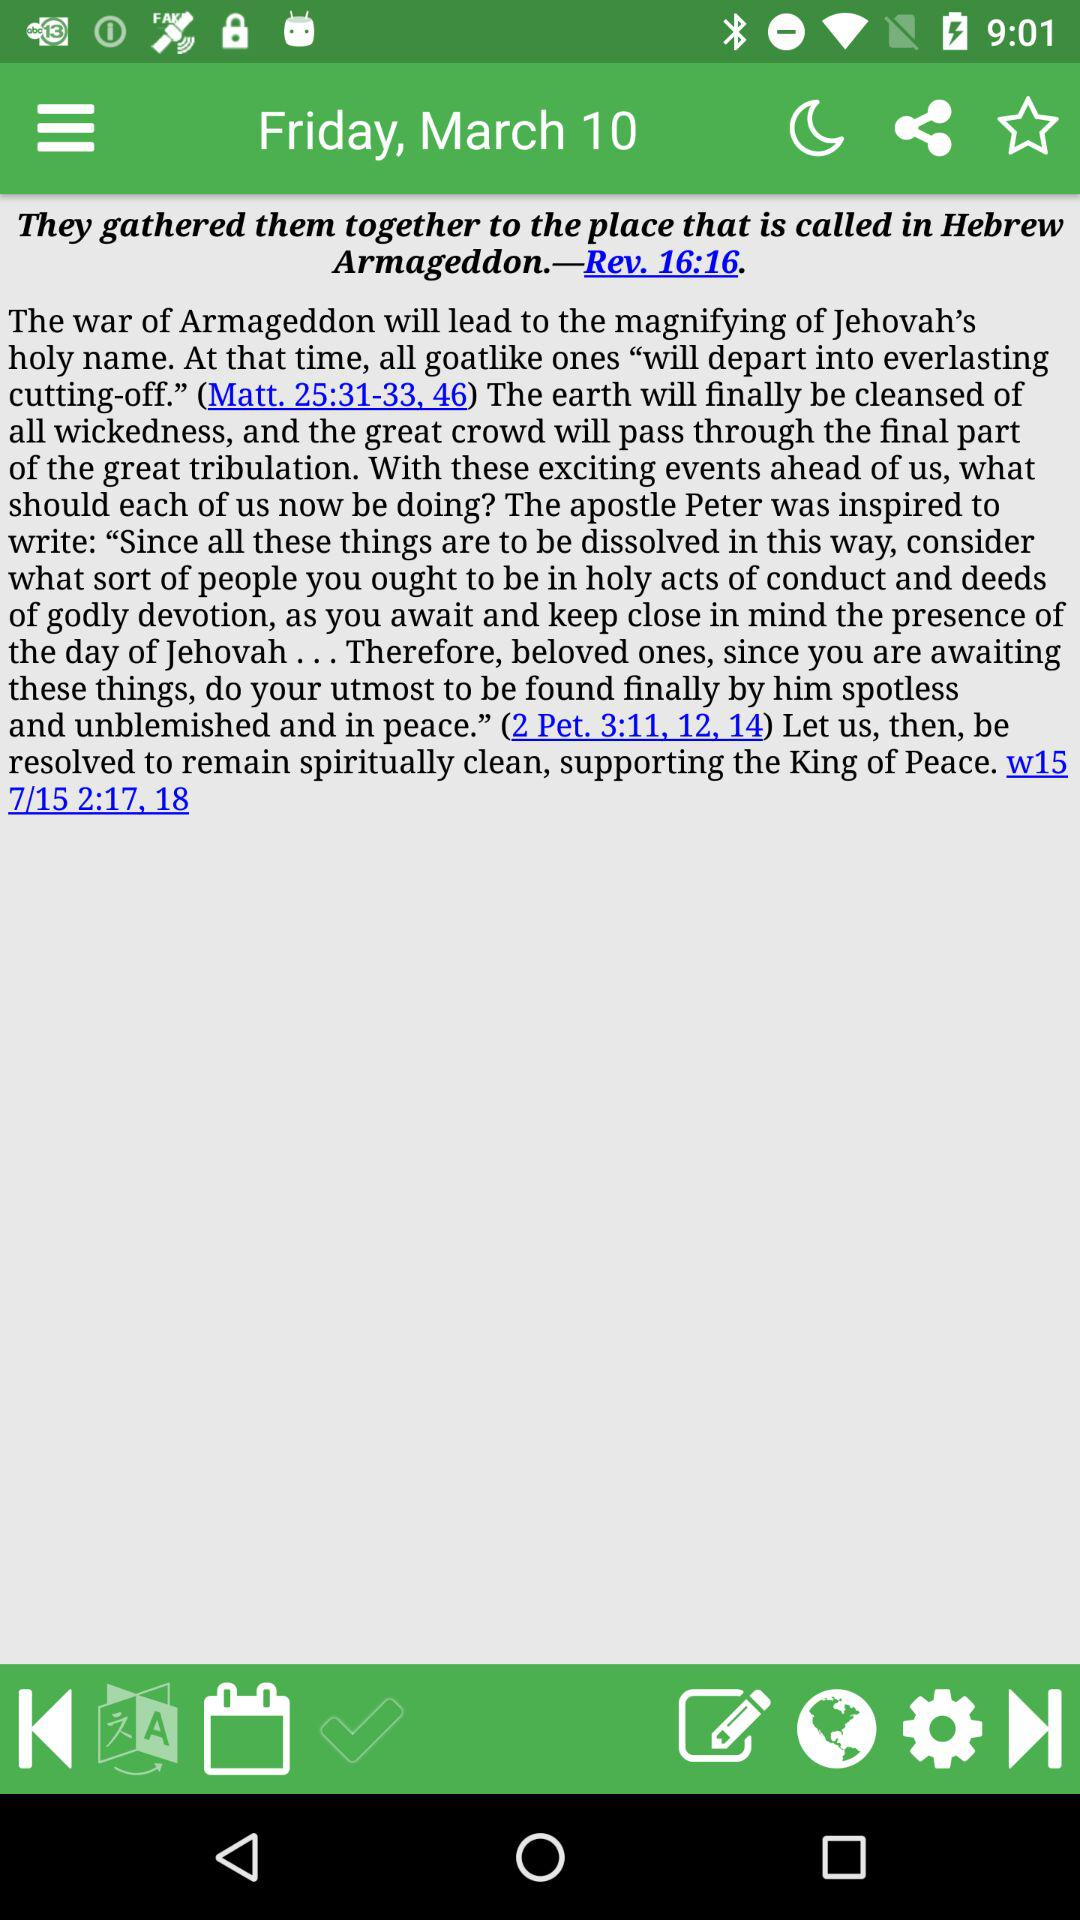What is the day on March 10? The day is Friday. 